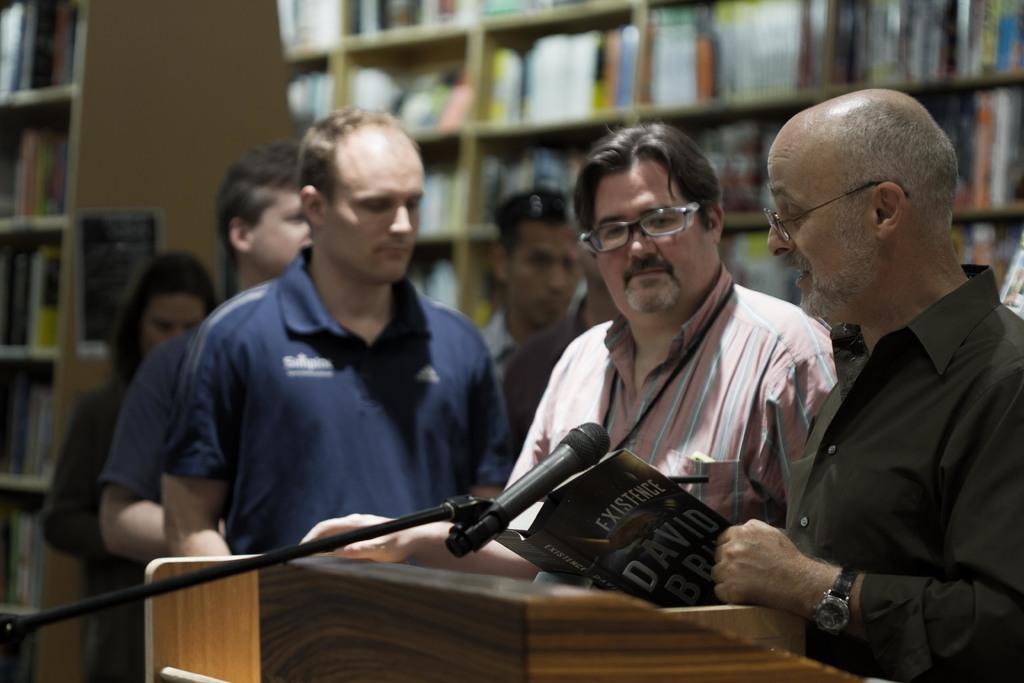What's the title of the book the man is holding?
Provide a succinct answer. Existence. What is the first name of the author?
Give a very brief answer. David. 